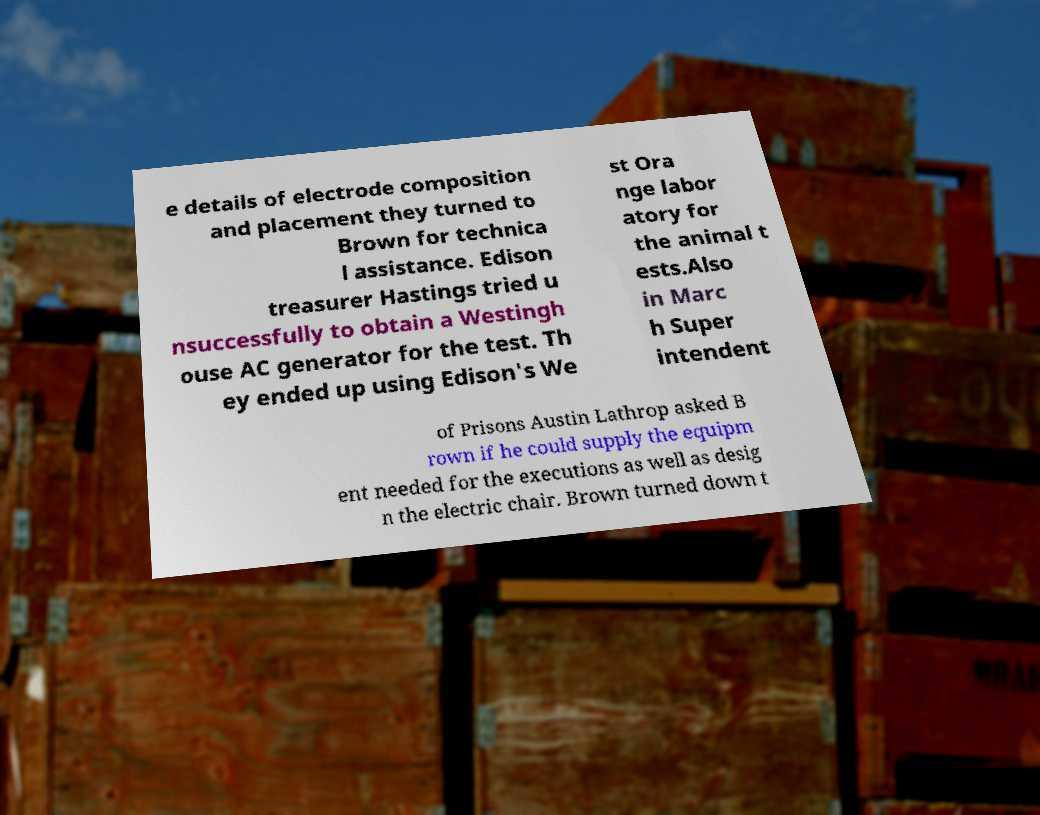What messages or text are displayed in this image? I need them in a readable, typed format. e details of electrode composition and placement they turned to Brown for technica l assistance. Edison treasurer Hastings tried u nsuccessfully to obtain a Westingh ouse AC generator for the test. Th ey ended up using Edison's We st Ora nge labor atory for the animal t ests.Also in Marc h Super intendent of Prisons Austin Lathrop asked B rown if he could supply the equipm ent needed for the executions as well as desig n the electric chair. Brown turned down t 